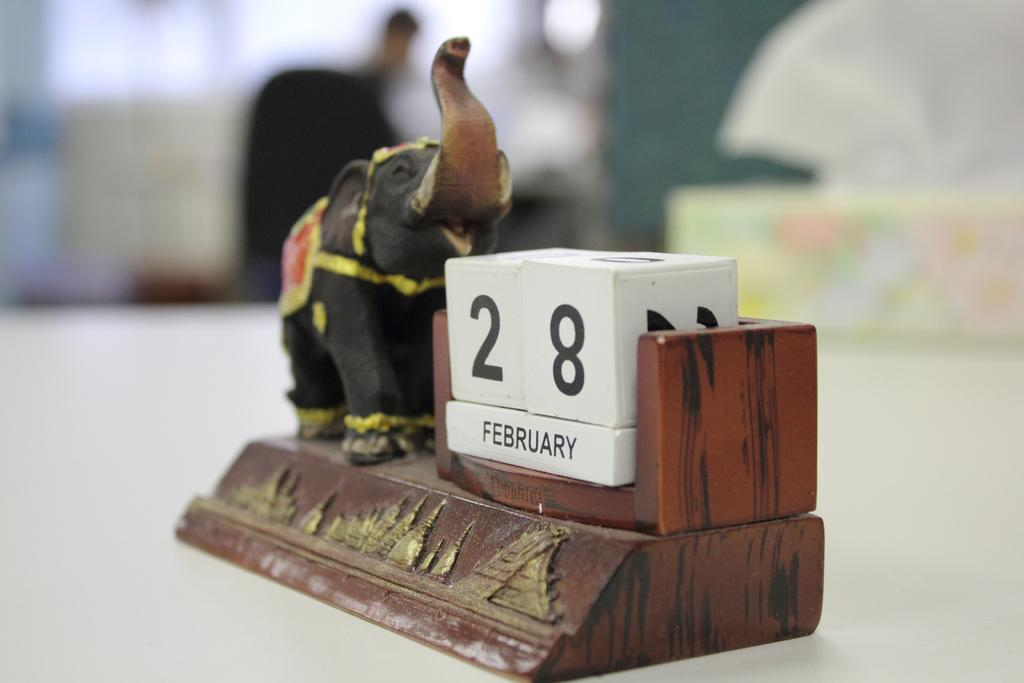What is the main subject of the image? There is an elephant toy in the image. Are there any other objects in the image besides the elephant toy? Yes, there are other objects in the image. What is the color of the surface on which the objects are placed? The objects are on a white surface. Can you describe the background of the image? The background of the image is blurred. What type of metal is the ball made of in the image? There is no ball present in the image, so it is not possible to determine what type of metal it might be made of. 